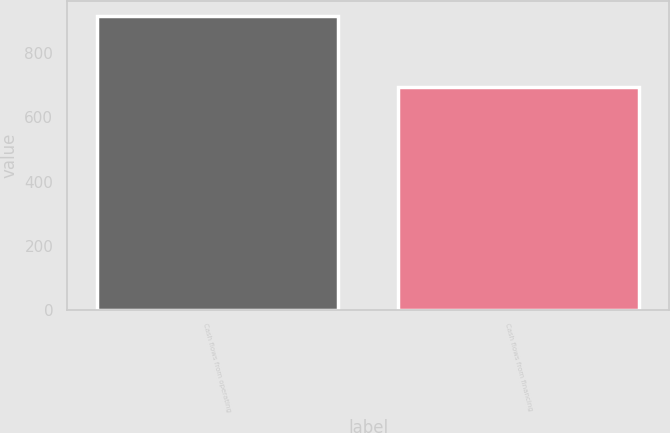Convert chart to OTSL. <chart><loc_0><loc_0><loc_500><loc_500><bar_chart><fcel>Cash flows from operating<fcel>Cash flows from financing<nl><fcel>916.5<fcel>694.8<nl></chart> 